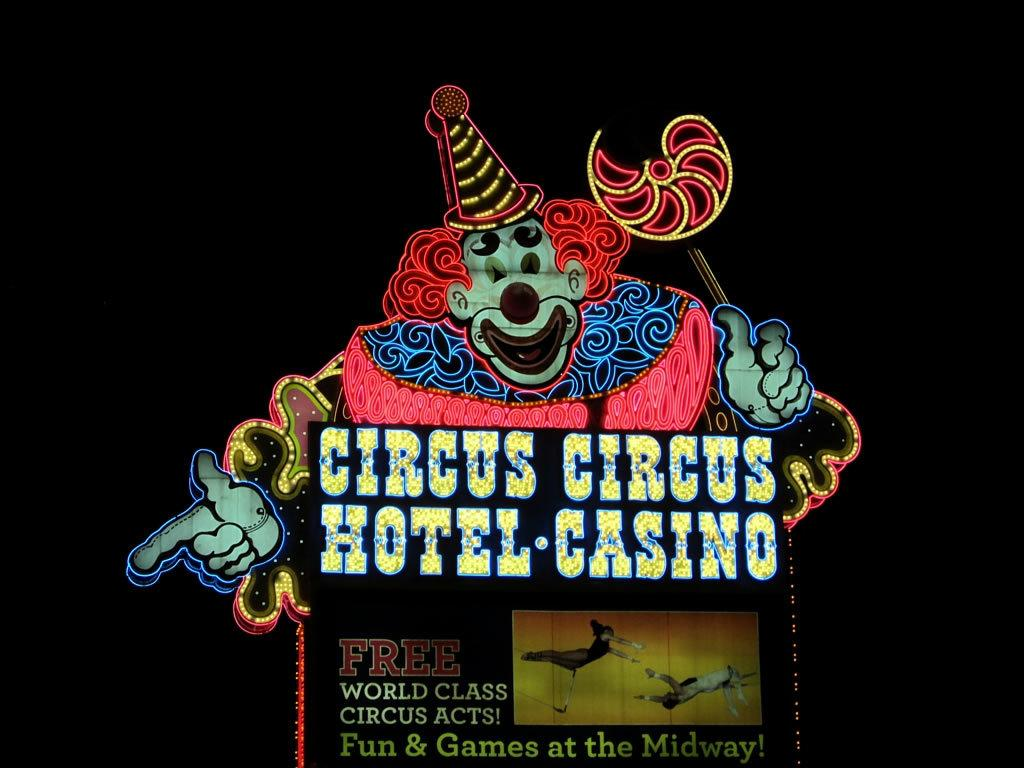<image>
Offer a succinct explanation of the picture presented. Billboard showing a clown on top for the Circus. 